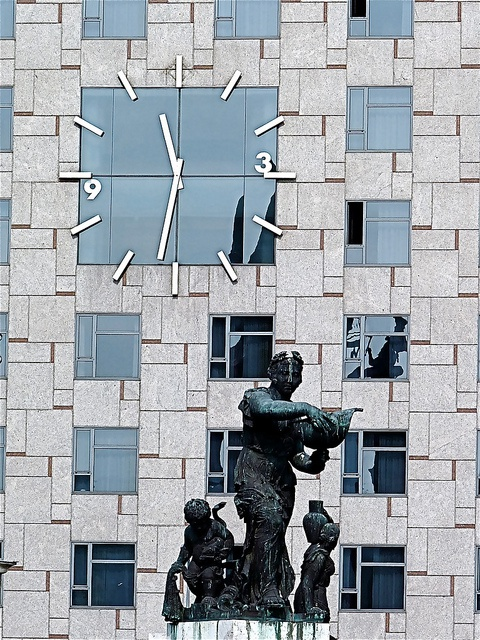Describe the objects in this image and their specific colors. I can see a clock in lightblue, darkgray, and white tones in this image. 